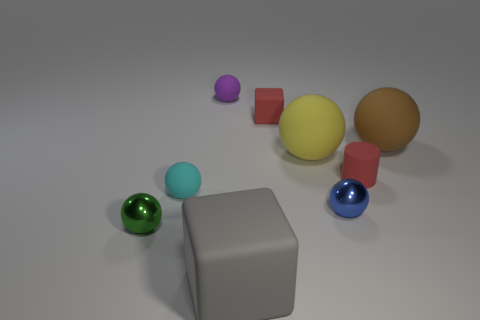What material is the green sphere that is the same size as the blue thing?
Give a very brief answer. Metal. What number of cylinders are either tiny red objects or cyan matte objects?
Ensure brevity in your answer.  1. The large gray matte thing has what shape?
Your response must be concise. Cube. There is a green sphere; are there any rubber blocks behind it?
Keep it short and to the point. Yes. Are the tiny cyan object and the small red object to the right of the tiny blue thing made of the same material?
Keep it short and to the point. Yes. Is the shape of the red thing on the left side of the tiny blue metal thing the same as  the gray object?
Your answer should be very brief. Yes. How many big blocks are made of the same material as the tiny cyan object?
Give a very brief answer. 1. How many things are matte spheres on the left side of the tiny red cylinder or gray rubber things?
Keep it short and to the point. 4. The yellow rubber object is what size?
Offer a very short reply. Large. What is the tiny red thing that is in front of the cube that is behind the tiny red cylinder made of?
Offer a very short reply. Rubber. 